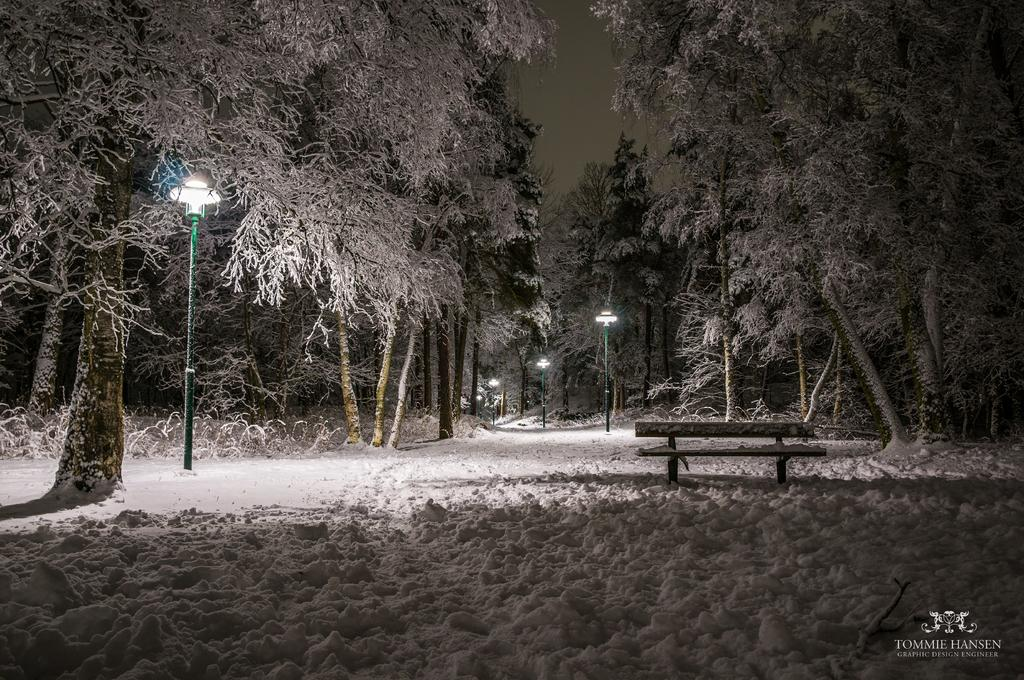What type of seating is visible in the image? There is a bench in the image. Where is the bench located? The bench is on land covered with snow. What other structures can be seen in the image? There are street lights in the image. What type of vegetation is present in the image? There are trees in the image, and they are covered with snow. What song is being sung by the giraffe in the image? There is no giraffe present in the image, and therefore no song can be heard or seen. 